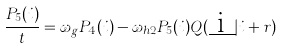<formula> <loc_0><loc_0><loc_500><loc_500>\frac { P _ { 5 } ( i ) } { t } = \omega _ { g } P _ { 4 } ( i ) - \omega _ { h 2 } P _ { 5 } ( i ) Q ( \underbar { i } | i + { r } )</formula> 